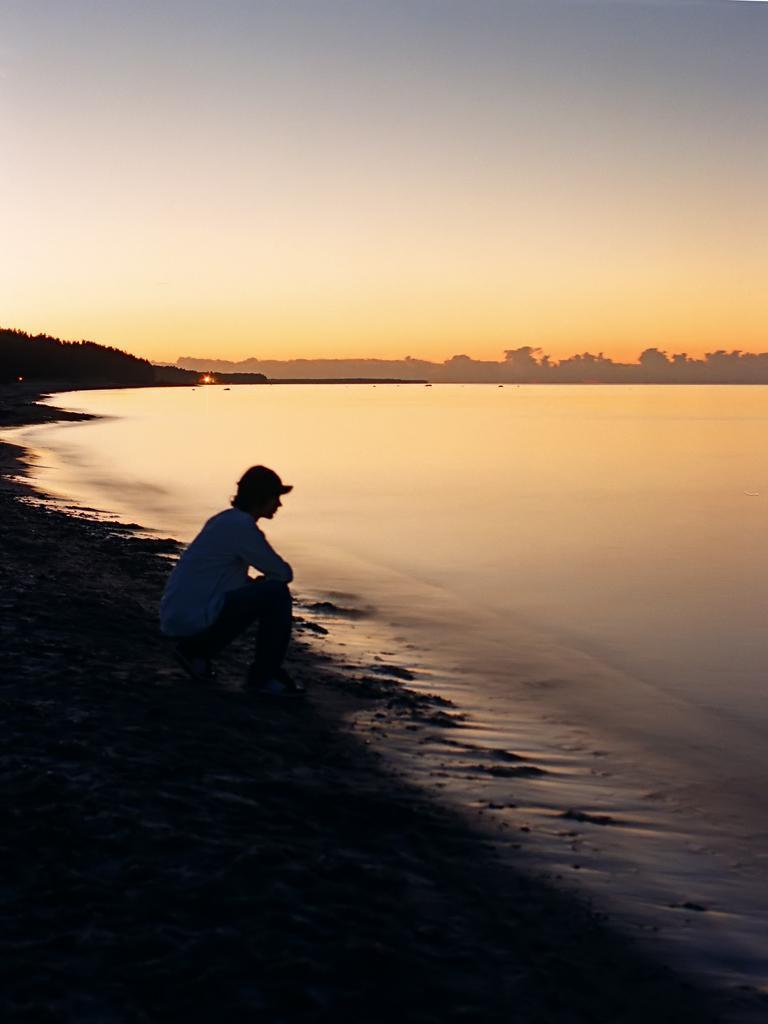How would you summarize this image in a sentence or two? In the picture I can see a person in the squat position is sitting on the sand and he is in the dark. Here I can see water, trees and the plain sky in the background. 